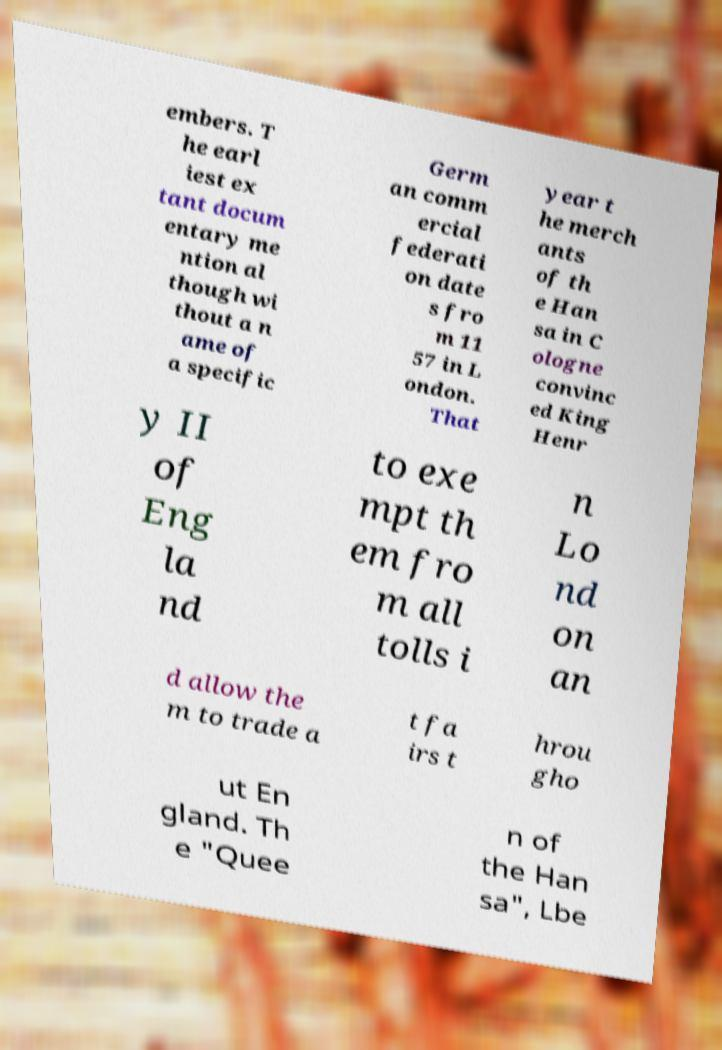Please identify and transcribe the text found in this image. embers. T he earl iest ex tant docum entary me ntion al though wi thout a n ame of a specific Germ an comm ercial federati on date s fro m 11 57 in L ondon. That year t he merch ants of th e Han sa in C ologne convinc ed King Henr y II of Eng la nd to exe mpt th em fro m all tolls i n Lo nd on an d allow the m to trade a t fa irs t hrou gho ut En gland. Th e "Quee n of the Han sa", Lbe 